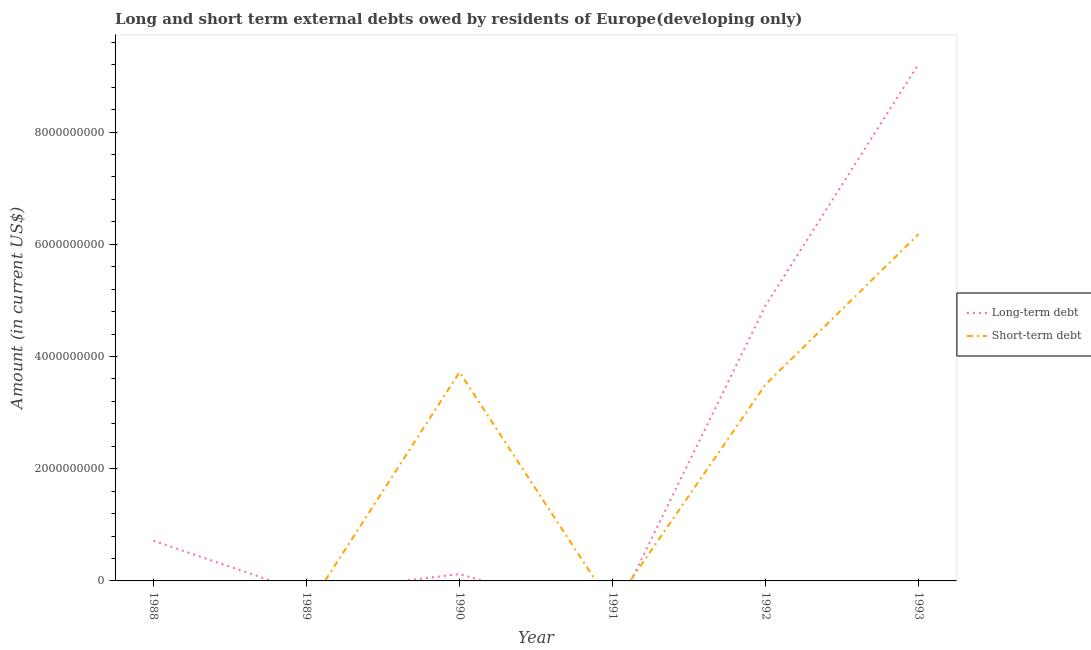What is the short-term debts owed by residents in 1989?
Provide a short and direct response. 0. Across all years, what is the maximum long-term debts owed by residents?
Offer a very short reply. 9.21e+09. What is the total long-term debts owed by residents in the graph?
Provide a short and direct response. 1.50e+1. What is the difference between the long-term debts owed by residents in 1992 and that in 1993?
Provide a short and direct response. -4.30e+09. What is the difference between the short-term debts owed by residents in 1991 and the long-term debts owed by residents in 1989?
Keep it short and to the point. 0. What is the average long-term debts owed by residents per year?
Ensure brevity in your answer.  2.49e+09. In the year 1990, what is the difference between the short-term debts owed by residents and long-term debts owed by residents?
Provide a succinct answer. 3.60e+09. What is the ratio of the long-term debts owed by residents in 1988 to that in 1990?
Give a very brief answer. 5.85. Is the difference between the short-term debts owed by residents in 1990 and 1993 greater than the difference between the long-term debts owed by residents in 1990 and 1993?
Provide a succinct answer. Yes. What is the difference between the highest and the second highest short-term debts owed by residents?
Your answer should be very brief. 2.46e+09. What is the difference between the highest and the lowest long-term debts owed by residents?
Provide a short and direct response. 9.21e+09. Is the long-term debts owed by residents strictly greater than the short-term debts owed by residents over the years?
Your answer should be compact. No. How many years are there in the graph?
Offer a terse response. 6. What is the difference between two consecutive major ticks on the Y-axis?
Ensure brevity in your answer.  2.00e+09. Does the graph contain grids?
Your answer should be very brief. No. How many legend labels are there?
Make the answer very short. 2. What is the title of the graph?
Your answer should be compact. Long and short term external debts owed by residents of Europe(developing only). What is the label or title of the X-axis?
Offer a terse response. Year. What is the Amount (in current US$) of Long-term debt in 1988?
Keep it short and to the point. 7.17e+08. What is the Amount (in current US$) in Short-term debt in 1988?
Your answer should be compact. 0. What is the Amount (in current US$) of Long-term debt in 1989?
Provide a succinct answer. 0. What is the Amount (in current US$) in Short-term debt in 1989?
Your answer should be very brief. 0. What is the Amount (in current US$) of Long-term debt in 1990?
Your answer should be compact. 1.23e+08. What is the Amount (in current US$) of Short-term debt in 1990?
Ensure brevity in your answer.  3.72e+09. What is the Amount (in current US$) in Long-term debt in 1992?
Your answer should be compact. 4.91e+09. What is the Amount (in current US$) in Short-term debt in 1992?
Your answer should be compact. 3.50e+09. What is the Amount (in current US$) in Long-term debt in 1993?
Keep it short and to the point. 9.21e+09. What is the Amount (in current US$) of Short-term debt in 1993?
Provide a succinct answer. 6.18e+09. Across all years, what is the maximum Amount (in current US$) in Long-term debt?
Make the answer very short. 9.21e+09. Across all years, what is the maximum Amount (in current US$) of Short-term debt?
Keep it short and to the point. 6.18e+09. What is the total Amount (in current US$) in Long-term debt in the graph?
Give a very brief answer. 1.50e+1. What is the total Amount (in current US$) of Short-term debt in the graph?
Your response must be concise. 1.34e+1. What is the difference between the Amount (in current US$) in Long-term debt in 1988 and that in 1990?
Make the answer very short. 5.94e+08. What is the difference between the Amount (in current US$) of Long-term debt in 1988 and that in 1992?
Give a very brief answer. -4.20e+09. What is the difference between the Amount (in current US$) of Long-term debt in 1988 and that in 1993?
Your response must be concise. -8.50e+09. What is the difference between the Amount (in current US$) in Long-term debt in 1990 and that in 1992?
Offer a terse response. -4.79e+09. What is the difference between the Amount (in current US$) of Short-term debt in 1990 and that in 1992?
Give a very brief answer. 2.17e+08. What is the difference between the Amount (in current US$) in Long-term debt in 1990 and that in 1993?
Offer a very short reply. -9.09e+09. What is the difference between the Amount (in current US$) of Short-term debt in 1990 and that in 1993?
Ensure brevity in your answer.  -2.46e+09. What is the difference between the Amount (in current US$) of Long-term debt in 1992 and that in 1993?
Provide a short and direct response. -4.30e+09. What is the difference between the Amount (in current US$) of Short-term debt in 1992 and that in 1993?
Ensure brevity in your answer.  -2.68e+09. What is the difference between the Amount (in current US$) in Long-term debt in 1988 and the Amount (in current US$) in Short-term debt in 1990?
Your answer should be very brief. -3.00e+09. What is the difference between the Amount (in current US$) of Long-term debt in 1988 and the Amount (in current US$) of Short-term debt in 1992?
Keep it short and to the point. -2.79e+09. What is the difference between the Amount (in current US$) in Long-term debt in 1988 and the Amount (in current US$) in Short-term debt in 1993?
Make the answer very short. -5.46e+09. What is the difference between the Amount (in current US$) of Long-term debt in 1990 and the Amount (in current US$) of Short-term debt in 1992?
Your response must be concise. -3.38e+09. What is the difference between the Amount (in current US$) in Long-term debt in 1990 and the Amount (in current US$) in Short-term debt in 1993?
Your response must be concise. -6.06e+09. What is the difference between the Amount (in current US$) in Long-term debt in 1992 and the Amount (in current US$) in Short-term debt in 1993?
Offer a very short reply. -1.27e+09. What is the average Amount (in current US$) of Long-term debt per year?
Make the answer very short. 2.49e+09. What is the average Amount (in current US$) of Short-term debt per year?
Provide a short and direct response. 2.23e+09. In the year 1990, what is the difference between the Amount (in current US$) in Long-term debt and Amount (in current US$) in Short-term debt?
Ensure brevity in your answer.  -3.60e+09. In the year 1992, what is the difference between the Amount (in current US$) in Long-term debt and Amount (in current US$) in Short-term debt?
Provide a short and direct response. 1.41e+09. In the year 1993, what is the difference between the Amount (in current US$) of Long-term debt and Amount (in current US$) of Short-term debt?
Give a very brief answer. 3.03e+09. What is the ratio of the Amount (in current US$) of Long-term debt in 1988 to that in 1990?
Make the answer very short. 5.85. What is the ratio of the Amount (in current US$) in Long-term debt in 1988 to that in 1992?
Give a very brief answer. 0.15. What is the ratio of the Amount (in current US$) of Long-term debt in 1988 to that in 1993?
Give a very brief answer. 0.08. What is the ratio of the Amount (in current US$) of Long-term debt in 1990 to that in 1992?
Ensure brevity in your answer.  0.03. What is the ratio of the Amount (in current US$) of Short-term debt in 1990 to that in 1992?
Your answer should be compact. 1.06. What is the ratio of the Amount (in current US$) in Long-term debt in 1990 to that in 1993?
Your response must be concise. 0.01. What is the ratio of the Amount (in current US$) of Short-term debt in 1990 to that in 1993?
Offer a very short reply. 0.6. What is the ratio of the Amount (in current US$) in Long-term debt in 1992 to that in 1993?
Provide a short and direct response. 0.53. What is the ratio of the Amount (in current US$) in Short-term debt in 1992 to that in 1993?
Provide a short and direct response. 0.57. What is the difference between the highest and the second highest Amount (in current US$) of Long-term debt?
Make the answer very short. 4.30e+09. What is the difference between the highest and the second highest Amount (in current US$) of Short-term debt?
Give a very brief answer. 2.46e+09. What is the difference between the highest and the lowest Amount (in current US$) of Long-term debt?
Offer a very short reply. 9.21e+09. What is the difference between the highest and the lowest Amount (in current US$) in Short-term debt?
Give a very brief answer. 6.18e+09. 